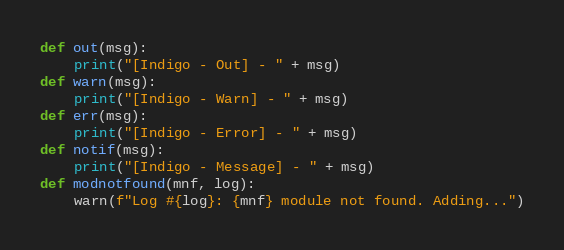Convert code to text. <code><loc_0><loc_0><loc_500><loc_500><_Python_>def out(msg):
    print("[Indigo - Out] - " + msg)
def warn(msg):
    print("[Indigo - Warn] - " + msg)
def err(msg):
    print("[Indigo - Error] - " + msg)
def notif(msg):
    print("[Indigo - Message] - " + msg)
def modnotfound(mnf, log):
    warn(f"Log #{log}: {mnf} module not found. Adding...")
</code> 